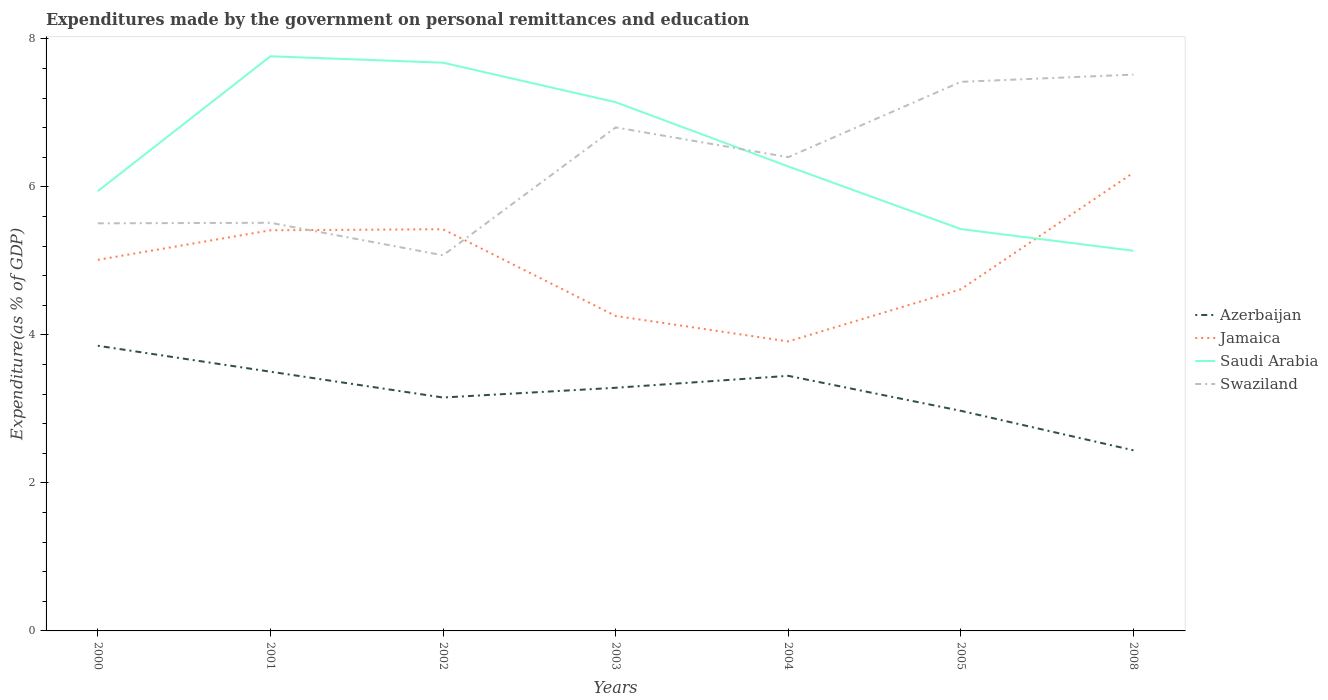How many different coloured lines are there?
Keep it short and to the point. 4. Does the line corresponding to Saudi Arabia intersect with the line corresponding to Jamaica?
Make the answer very short. Yes. Across all years, what is the maximum expenditures made by the government on personal remittances and education in Azerbaijan?
Make the answer very short. 2.44. What is the total expenditures made by the government on personal remittances and education in Azerbaijan in the graph?
Provide a short and direct response. 1.41. What is the difference between the highest and the second highest expenditures made by the government on personal remittances and education in Saudi Arabia?
Provide a succinct answer. 2.63. What is the difference between the highest and the lowest expenditures made by the government on personal remittances and education in Azerbaijan?
Ensure brevity in your answer.  4. Is the expenditures made by the government on personal remittances and education in Swaziland strictly greater than the expenditures made by the government on personal remittances and education in Jamaica over the years?
Provide a succinct answer. No. How many years are there in the graph?
Offer a terse response. 7. What is the difference between two consecutive major ticks on the Y-axis?
Offer a very short reply. 2. Are the values on the major ticks of Y-axis written in scientific E-notation?
Provide a short and direct response. No. Does the graph contain any zero values?
Your answer should be very brief. No. Does the graph contain grids?
Provide a short and direct response. No. Where does the legend appear in the graph?
Give a very brief answer. Center right. How many legend labels are there?
Provide a short and direct response. 4. What is the title of the graph?
Your answer should be very brief. Expenditures made by the government on personal remittances and education. Does "Hong Kong" appear as one of the legend labels in the graph?
Keep it short and to the point. No. What is the label or title of the Y-axis?
Provide a succinct answer. Expenditure(as % of GDP). What is the Expenditure(as % of GDP) of Azerbaijan in 2000?
Give a very brief answer. 3.85. What is the Expenditure(as % of GDP) of Jamaica in 2000?
Keep it short and to the point. 5.02. What is the Expenditure(as % of GDP) in Saudi Arabia in 2000?
Offer a very short reply. 5.94. What is the Expenditure(as % of GDP) in Swaziland in 2000?
Your answer should be compact. 5.51. What is the Expenditure(as % of GDP) in Azerbaijan in 2001?
Offer a very short reply. 3.5. What is the Expenditure(as % of GDP) in Jamaica in 2001?
Make the answer very short. 5.41. What is the Expenditure(as % of GDP) of Saudi Arabia in 2001?
Your answer should be compact. 7.77. What is the Expenditure(as % of GDP) of Swaziland in 2001?
Your response must be concise. 5.52. What is the Expenditure(as % of GDP) of Azerbaijan in 2002?
Your answer should be very brief. 3.15. What is the Expenditure(as % of GDP) in Jamaica in 2002?
Make the answer very short. 5.43. What is the Expenditure(as % of GDP) of Saudi Arabia in 2002?
Your response must be concise. 7.68. What is the Expenditure(as % of GDP) of Swaziland in 2002?
Provide a short and direct response. 5.08. What is the Expenditure(as % of GDP) in Azerbaijan in 2003?
Offer a very short reply. 3.29. What is the Expenditure(as % of GDP) of Jamaica in 2003?
Offer a terse response. 4.26. What is the Expenditure(as % of GDP) in Saudi Arabia in 2003?
Keep it short and to the point. 7.15. What is the Expenditure(as % of GDP) of Swaziland in 2003?
Make the answer very short. 6.81. What is the Expenditure(as % of GDP) of Azerbaijan in 2004?
Offer a terse response. 3.45. What is the Expenditure(as % of GDP) in Jamaica in 2004?
Make the answer very short. 3.91. What is the Expenditure(as % of GDP) in Saudi Arabia in 2004?
Provide a succinct answer. 6.28. What is the Expenditure(as % of GDP) of Swaziland in 2004?
Provide a succinct answer. 6.4. What is the Expenditure(as % of GDP) of Azerbaijan in 2005?
Give a very brief answer. 2.97. What is the Expenditure(as % of GDP) in Jamaica in 2005?
Your answer should be compact. 4.62. What is the Expenditure(as % of GDP) of Saudi Arabia in 2005?
Provide a succinct answer. 5.43. What is the Expenditure(as % of GDP) of Swaziland in 2005?
Your answer should be compact. 7.42. What is the Expenditure(as % of GDP) in Azerbaijan in 2008?
Offer a very short reply. 2.44. What is the Expenditure(as % of GDP) of Jamaica in 2008?
Your answer should be compact. 6.19. What is the Expenditure(as % of GDP) in Saudi Arabia in 2008?
Offer a terse response. 5.14. What is the Expenditure(as % of GDP) of Swaziland in 2008?
Offer a very short reply. 7.52. Across all years, what is the maximum Expenditure(as % of GDP) of Azerbaijan?
Your response must be concise. 3.85. Across all years, what is the maximum Expenditure(as % of GDP) of Jamaica?
Give a very brief answer. 6.19. Across all years, what is the maximum Expenditure(as % of GDP) of Saudi Arabia?
Your answer should be compact. 7.77. Across all years, what is the maximum Expenditure(as % of GDP) in Swaziland?
Keep it short and to the point. 7.52. Across all years, what is the minimum Expenditure(as % of GDP) of Azerbaijan?
Keep it short and to the point. 2.44. Across all years, what is the minimum Expenditure(as % of GDP) in Jamaica?
Your answer should be very brief. 3.91. Across all years, what is the minimum Expenditure(as % of GDP) in Saudi Arabia?
Offer a terse response. 5.14. Across all years, what is the minimum Expenditure(as % of GDP) in Swaziland?
Make the answer very short. 5.08. What is the total Expenditure(as % of GDP) in Azerbaijan in the graph?
Your answer should be very brief. 22.66. What is the total Expenditure(as % of GDP) in Jamaica in the graph?
Your response must be concise. 34.84. What is the total Expenditure(as % of GDP) of Saudi Arabia in the graph?
Provide a succinct answer. 45.38. What is the total Expenditure(as % of GDP) in Swaziland in the graph?
Provide a short and direct response. 44.25. What is the difference between the Expenditure(as % of GDP) of Azerbaijan in 2000 and that in 2001?
Offer a terse response. 0.35. What is the difference between the Expenditure(as % of GDP) of Jamaica in 2000 and that in 2001?
Give a very brief answer. -0.4. What is the difference between the Expenditure(as % of GDP) of Saudi Arabia in 2000 and that in 2001?
Keep it short and to the point. -1.82. What is the difference between the Expenditure(as % of GDP) in Swaziland in 2000 and that in 2001?
Provide a succinct answer. -0.01. What is the difference between the Expenditure(as % of GDP) in Azerbaijan in 2000 and that in 2002?
Make the answer very short. 0.7. What is the difference between the Expenditure(as % of GDP) of Jamaica in 2000 and that in 2002?
Offer a terse response. -0.41. What is the difference between the Expenditure(as % of GDP) of Saudi Arabia in 2000 and that in 2002?
Give a very brief answer. -1.74. What is the difference between the Expenditure(as % of GDP) of Swaziland in 2000 and that in 2002?
Offer a terse response. 0.43. What is the difference between the Expenditure(as % of GDP) in Azerbaijan in 2000 and that in 2003?
Your answer should be very brief. 0.57. What is the difference between the Expenditure(as % of GDP) in Jamaica in 2000 and that in 2003?
Your answer should be very brief. 0.76. What is the difference between the Expenditure(as % of GDP) in Saudi Arabia in 2000 and that in 2003?
Your answer should be very brief. -1.2. What is the difference between the Expenditure(as % of GDP) of Swaziland in 2000 and that in 2003?
Give a very brief answer. -1.3. What is the difference between the Expenditure(as % of GDP) of Azerbaijan in 2000 and that in 2004?
Your response must be concise. 0.41. What is the difference between the Expenditure(as % of GDP) in Jamaica in 2000 and that in 2004?
Offer a terse response. 1.1. What is the difference between the Expenditure(as % of GDP) in Saudi Arabia in 2000 and that in 2004?
Ensure brevity in your answer.  -0.33. What is the difference between the Expenditure(as % of GDP) in Swaziland in 2000 and that in 2004?
Provide a short and direct response. -0.89. What is the difference between the Expenditure(as % of GDP) of Azerbaijan in 2000 and that in 2005?
Your response must be concise. 0.88. What is the difference between the Expenditure(as % of GDP) in Jamaica in 2000 and that in 2005?
Provide a short and direct response. 0.4. What is the difference between the Expenditure(as % of GDP) of Saudi Arabia in 2000 and that in 2005?
Your answer should be compact. 0.51. What is the difference between the Expenditure(as % of GDP) in Swaziland in 2000 and that in 2005?
Provide a short and direct response. -1.91. What is the difference between the Expenditure(as % of GDP) in Azerbaijan in 2000 and that in 2008?
Provide a succinct answer. 1.41. What is the difference between the Expenditure(as % of GDP) in Jamaica in 2000 and that in 2008?
Keep it short and to the point. -1.18. What is the difference between the Expenditure(as % of GDP) of Saudi Arabia in 2000 and that in 2008?
Offer a terse response. 0.81. What is the difference between the Expenditure(as % of GDP) in Swaziland in 2000 and that in 2008?
Your answer should be compact. -2.01. What is the difference between the Expenditure(as % of GDP) in Azerbaijan in 2001 and that in 2002?
Ensure brevity in your answer.  0.35. What is the difference between the Expenditure(as % of GDP) of Jamaica in 2001 and that in 2002?
Offer a terse response. -0.01. What is the difference between the Expenditure(as % of GDP) in Saudi Arabia in 2001 and that in 2002?
Provide a succinct answer. 0.09. What is the difference between the Expenditure(as % of GDP) of Swaziland in 2001 and that in 2002?
Your answer should be very brief. 0.44. What is the difference between the Expenditure(as % of GDP) in Azerbaijan in 2001 and that in 2003?
Offer a terse response. 0.22. What is the difference between the Expenditure(as % of GDP) of Jamaica in 2001 and that in 2003?
Ensure brevity in your answer.  1.16. What is the difference between the Expenditure(as % of GDP) of Saudi Arabia in 2001 and that in 2003?
Your response must be concise. 0.62. What is the difference between the Expenditure(as % of GDP) of Swaziland in 2001 and that in 2003?
Offer a very short reply. -1.29. What is the difference between the Expenditure(as % of GDP) of Azerbaijan in 2001 and that in 2004?
Ensure brevity in your answer.  0.06. What is the difference between the Expenditure(as % of GDP) in Jamaica in 2001 and that in 2004?
Give a very brief answer. 1.5. What is the difference between the Expenditure(as % of GDP) in Saudi Arabia in 2001 and that in 2004?
Make the answer very short. 1.49. What is the difference between the Expenditure(as % of GDP) of Swaziland in 2001 and that in 2004?
Your response must be concise. -0.89. What is the difference between the Expenditure(as % of GDP) of Azerbaijan in 2001 and that in 2005?
Ensure brevity in your answer.  0.53. What is the difference between the Expenditure(as % of GDP) in Jamaica in 2001 and that in 2005?
Offer a very short reply. 0.8. What is the difference between the Expenditure(as % of GDP) of Saudi Arabia in 2001 and that in 2005?
Your response must be concise. 2.34. What is the difference between the Expenditure(as % of GDP) of Swaziland in 2001 and that in 2005?
Your response must be concise. -1.9. What is the difference between the Expenditure(as % of GDP) of Jamaica in 2001 and that in 2008?
Make the answer very short. -0.78. What is the difference between the Expenditure(as % of GDP) in Saudi Arabia in 2001 and that in 2008?
Give a very brief answer. 2.63. What is the difference between the Expenditure(as % of GDP) of Swaziland in 2001 and that in 2008?
Your answer should be compact. -2. What is the difference between the Expenditure(as % of GDP) in Azerbaijan in 2002 and that in 2003?
Give a very brief answer. -0.13. What is the difference between the Expenditure(as % of GDP) of Jamaica in 2002 and that in 2003?
Your answer should be very brief. 1.17. What is the difference between the Expenditure(as % of GDP) in Saudi Arabia in 2002 and that in 2003?
Make the answer very short. 0.53. What is the difference between the Expenditure(as % of GDP) in Swaziland in 2002 and that in 2003?
Your response must be concise. -1.73. What is the difference between the Expenditure(as % of GDP) of Azerbaijan in 2002 and that in 2004?
Make the answer very short. -0.29. What is the difference between the Expenditure(as % of GDP) in Jamaica in 2002 and that in 2004?
Make the answer very short. 1.52. What is the difference between the Expenditure(as % of GDP) in Saudi Arabia in 2002 and that in 2004?
Give a very brief answer. 1.4. What is the difference between the Expenditure(as % of GDP) of Swaziland in 2002 and that in 2004?
Provide a succinct answer. -1.33. What is the difference between the Expenditure(as % of GDP) of Azerbaijan in 2002 and that in 2005?
Your response must be concise. 0.18. What is the difference between the Expenditure(as % of GDP) in Jamaica in 2002 and that in 2005?
Your answer should be compact. 0.81. What is the difference between the Expenditure(as % of GDP) of Saudi Arabia in 2002 and that in 2005?
Your answer should be compact. 2.25. What is the difference between the Expenditure(as % of GDP) in Swaziland in 2002 and that in 2005?
Keep it short and to the point. -2.34. What is the difference between the Expenditure(as % of GDP) in Azerbaijan in 2002 and that in 2008?
Offer a very short reply. 0.71. What is the difference between the Expenditure(as % of GDP) of Jamaica in 2002 and that in 2008?
Offer a very short reply. -0.76. What is the difference between the Expenditure(as % of GDP) in Saudi Arabia in 2002 and that in 2008?
Keep it short and to the point. 2.54. What is the difference between the Expenditure(as % of GDP) of Swaziland in 2002 and that in 2008?
Make the answer very short. -2.44. What is the difference between the Expenditure(as % of GDP) in Azerbaijan in 2003 and that in 2004?
Keep it short and to the point. -0.16. What is the difference between the Expenditure(as % of GDP) of Jamaica in 2003 and that in 2004?
Provide a short and direct response. 0.34. What is the difference between the Expenditure(as % of GDP) in Saudi Arabia in 2003 and that in 2004?
Your answer should be compact. 0.87. What is the difference between the Expenditure(as % of GDP) in Swaziland in 2003 and that in 2004?
Offer a very short reply. 0.4. What is the difference between the Expenditure(as % of GDP) of Azerbaijan in 2003 and that in 2005?
Provide a short and direct response. 0.31. What is the difference between the Expenditure(as % of GDP) of Jamaica in 2003 and that in 2005?
Give a very brief answer. -0.36. What is the difference between the Expenditure(as % of GDP) in Saudi Arabia in 2003 and that in 2005?
Offer a very short reply. 1.72. What is the difference between the Expenditure(as % of GDP) in Swaziland in 2003 and that in 2005?
Give a very brief answer. -0.62. What is the difference between the Expenditure(as % of GDP) in Azerbaijan in 2003 and that in 2008?
Your answer should be very brief. 0.85. What is the difference between the Expenditure(as % of GDP) of Jamaica in 2003 and that in 2008?
Your answer should be compact. -1.94. What is the difference between the Expenditure(as % of GDP) of Saudi Arabia in 2003 and that in 2008?
Your answer should be very brief. 2.01. What is the difference between the Expenditure(as % of GDP) in Swaziland in 2003 and that in 2008?
Your response must be concise. -0.71. What is the difference between the Expenditure(as % of GDP) in Azerbaijan in 2004 and that in 2005?
Offer a terse response. 0.47. What is the difference between the Expenditure(as % of GDP) of Jamaica in 2004 and that in 2005?
Your answer should be very brief. -0.7. What is the difference between the Expenditure(as % of GDP) in Saudi Arabia in 2004 and that in 2005?
Provide a succinct answer. 0.85. What is the difference between the Expenditure(as % of GDP) in Swaziland in 2004 and that in 2005?
Ensure brevity in your answer.  -1.02. What is the difference between the Expenditure(as % of GDP) of Azerbaijan in 2004 and that in 2008?
Your answer should be compact. 1.01. What is the difference between the Expenditure(as % of GDP) of Jamaica in 2004 and that in 2008?
Ensure brevity in your answer.  -2.28. What is the difference between the Expenditure(as % of GDP) of Saudi Arabia in 2004 and that in 2008?
Make the answer very short. 1.14. What is the difference between the Expenditure(as % of GDP) in Swaziland in 2004 and that in 2008?
Give a very brief answer. -1.12. What is the difference between the Expenditure(as % of GDP) of Azerbaijan in 2005 and that in 2008?
Give a very brief answer. 0.53. What is the difference between the Expenditure(as % of GDP) in Jamaica in 2005 and that in 2008?
Offer a very short reply. -1.58. What is the difference between the Expenditure(as % of GDP) in Saudi Arabia in 2005 and that in 2008?
Your response must be concise. 0.29. What is the difference between the Expenditure(as % of GDP) in Swaziland in 2005 and that in 2008?
Your answer should be very brief. -0.1. What is the difference between the Expenditure(as % of GDP) in Azerbaijan in 2000 and the Expenditure(as % of GDP) in Jamaica in 2001?
Your answer should be compact. -1.56. What is the difference between the Expenditure(as % of GDP) in Azerbaijan in 2000 and the Expenditure(as % of GDP) in Saudi Arabia in 2001?
Your answer should be very brief. -3.91. What is the difference between the Expenditure(as % of GDP) in Azerbaijan in 2000 and the Expenditure(as % of GDP) in Swaziland in 2001?
Your answer should be compact. -1.66. What is the difference between the Expenditure(as % of GDP) of Jamaica in 2000 and the Expenditure(as % of GDP) of Saudi Arabia in 2001?
Make the answer very short. -2.75. What is the difference between the Expenditure(as % of GDP) of Jamaica in 2000 and the Expenditure(as % of GDP) of Swaziland in 2001?
Your answer should be very brief. -0.5. What is the difference between the Expenditure(as % of GDP) of Saudi Arabia in 2000 and the Expenditure(as % of GDP) of Swaziland in 2001?
Give a very brief answer. 0.43. What is the difference between the Expenditure(as % of GDP) in Azerbaijan in 2000 and the Expenditure(as % of GDP) in Jamaica in 2002?
Give a very brief answer. -1.57. What is the difference between the Expenditure(as % of GDP) in Azerbaijan in 2000 and the Expenditure(as % of GDP) in Saudi Arabia in 2002?
Keep it short and to the point. -3.83. What is the difference between the Expenditure(as % of GDP) in Azerbaijan in 2000 and the Expenditure(as % of GDP) in Swaziland in 2002?
Your answer should be very brief. -1.22. What is the difference between the Expenditure(as % of GDP) in Jamaica in 2000 and the Expenditure(as % of GDP) in Saudi Arabia in 2002?
Make the answer very short. -2.66. What is the difference between the Expenditure(as % of GDP) of Jamaica in 2000 and the Expenditure(as % of GDP) of Swaziland in 2002?
Give a very brief answer. -0.06. What is the difference between the Expenditure(as % of GDP) of Saudi Arabia in 2000 and the Expenditure(as % of GDP) of Swaziland in 2002?
Offer a terse response. 0.87. What is the difference between the Expenditure(as % of GDP) in Azerbaijan in 2000 and the Expenditure(as % of GDP) in Jamaica in 2003?
Keep it short and to the point. -0.4. What is the difference between the Expenditure(as % of GDP) of Azerbaijan in 2000 and the Expenditure(as % of GDP) of Saudi Arabia in 2003?
Keep it short and to the point. -3.29. What is the difference between the Expenditure(as % of GDP) in Azerbaijan in 2000 and the Expenditure(as % of GDP) in Swaziland in 2003?
Keep it short and to the point. -2.95. What is the difference between the Expenditure(as % of GDP) of Jamaica in 2000 and the Expenditure(as % of GDP) of Saudi Arabia in 2003?
Make the answer very short. -2.13. What is the difference between the Expenditure(as % of GDP) of Jamaica in 2000 and the Expenditure(as % of GDP) of Swaziland in 2003?
Your answer should be compact. -1.79. What is the difference between the Expenditure(as % of GDP) of Saudi Arabia in 2000 and the Expenditure(as % of GDP) of Swaziland in 2003?
Provide a short and direct response. -0.86. What is the difference between the Expenditure(as % of GDP) in Azerbaijan in 2000 and the Expenditure(as % of GDP) in Jamaica in 2004?
Provide a short and direct response. -0.06. What is the difference between the Expenditure(as % of GDP) in Azerbaijan in 2000 and the Expenditure(as % of GDP) in Saudi Arabia in 2004?
Give a very brief answer. -2.42. What is the difference between the Expenditure(as % of GDP) in Azerbaijan in 2000 and the Expenditure(as % of GDP) in Swaziland in 2004?
Provide a succinct answer. -2.55. What is the difference between the Expenditure(as % of GDP) of Jamaica in 2000 and the Expenditure(as % of GDP) of Saudi Arabia in 2004?
Offer a very short reply. -1.26. What is the difference between the Expenditure(as % of GDP) of Jamaica in 2000 and the Expenditure(as % of GDP) of Swaziland in 2004?
Offer a very short reply. -1.39. What is the difference between the Expenditure(as % of GDP) in Saudi Arabia in 2000 and the Expenditure(as % of GDP) in Swaziland in 2004?
Offer a terse response. -0.46. What is the difference between the Expenditure(as % of GDP) in Azerbaijan in 2000 and the Expenditure(as % of GDP) in Jamaica in 2005?
Your answer should be compact. -0.76. What is the difference between the Expenditure(as % of GDP) in Azerbaijan in 2000 and the Expenditure(as % of GDP) in Saudi Arabia in 2005?
Provide a short and direct response. -1.58. What is the difference between the Expenditure(as % of GDP) in Azerbaijan in 2000 and the Expenditure(as % of GDP) in Swaziland in 2005?
Make the answer very short. -3.57. What is the difference between the Expenditure(as % of GDP) in Jamaica in 2000 and the Expenditure(as % of GDP) in Saudi Arabia in 2005?
Give a very brief answer. -0.42. What is the difference between the Expenditure(as % of GDP) of Jamaica in 2000 and the Expenditure(as % of GDP) of Swaziland in 2005?
Your response must be concise. -2.41. What is the difference between the Expenditure(as % of GDP) of Saudi Arabia in 2000 and the Expenditure(as % of GDP) of Swaziland in 2005?
Provide a succinct answer. -1.48. What is the difference between the Expenditure(as % of GDP) of Azerbaijan in 2000 and the Expenditure(as % of GDP) of Jamaica in 2008?
Provide a short and direct response. -2.34. What is the difference between the Expenditure(as % of GDP) in Azerbaijan in 2000 and the Expenditure(as % of GDP) in Saudi Arabia in 2008?
Your answer should be compact. -1.28. What is the difference between the Expenditure(as % of GDP) of Azerbaijan in 2000 and the Expenditure(as % of GDP) of Swaziland in 2008?
Ensure brevity in your answer.  -3.66. What is the difference between the Expenditure(as % of GDP) of Jamaica in 2000 and the Expenditure(as % of GDP) of Saudi Arabia in 2008?
Your answer should be very brief. -0.12. What is the difference between the Expenditure(as % of GDP) in Jamaica in 2000 and the Expenditure(as % of GDP) in Swaziland in 2008?
Your answer should be very brief. -2.5. What is the difference between the Expenditure(as % of GDP) of Saudi Arabia in 2000 and the Expenditure(as % of GDP) of Swaziland in 2008?
Give a very brief answer. -1.58. What is the difference between the Expenditure(as % of GDP) of Azerbaijan in 2001 and the Expenditure(as % of GDP) of Jamaica in 2002?
Ensure brevity in your answer.  -1.93. What is the difference between the Expenditure(as % of GDP) in Azerbaijan in 2001 and the Expenditure(as % of GDP) in Saudi Arabia in 2002?
Ensure brevity in your answer.  -4.18. What is the difference between the Expenditure(as % of GDP) in Azerbaijan in 2001 and the Expenditure(as % of GDP) in Swaziland in 2002?
Provide a short and direct response. -1.57. What is the difference between the Expenditure(as % of GDP) of Jamaica in 2001 and the Expenditure(as % of GDP) of Saudi Arabia in 2002?
Keep it short and to the point. -2.26. What is the difference between the Expenditure(as % of GDP) in Jamaica in 2001 and the Expenditure(as % of GDP) in Swaziland in 2002?
Your response must be concise. 0.34. What is the difference between the Expenditure(as % of GDP) of Saudi Arabia in 2001 and the Expenditure(as % of GDP) of Swaziland in 2002?
Your answer should be compact. 2.69. What is the difference between the Expenditure(as % of GDP) of Azerbaijan in 2001 and the Expenditure(as % of GDP) of Jamaica in 2003?
Give a very brief answer. -0.75. What is the difference between the Expenditure(as % of GDP) in Azerbaijan in 2001 and the Expenditure(as % of GDP) in Saudi Arabia in 2003?
Give a very brief answer. -3.64. What is the difference between the Expenditure(as % of GDP) in Azerbaijan in 2001 and the Expenditure(as % of GDP) in Swaziland in 2003?
Offer a terse response. -3.3. What is the difference between the Expenditure(as % of GDP) of Jamaica in 2001 and the Expenditure(as % of GDP) of Saudi Arabia in 2003?
Keep it short and to the point. -1.73. What is the difference between the Expenditure(as % of GDP) in Jamaica in 2001 and the Expenditure(as % of GDP) in Swaziland in 2003?
Your answer should be compact. -1.39. What is the difference between the Expenditure(as % of GDP) of Saudi Arabia in 2001 and the Expenditure(as % of GDP) of Swaziland in 2003?
Provide a short and direct response. 0.96. What is the difference between the Expenditure(as % of GDP) of Azerbaijan in 2001 and the Expenditure(as % of GDP) of Jamaica in 2004?
Provide a short and direct response. -0.41. What is the difference between the Expenditure(as % of GDP) in Azerbaijan in 2001 and the Expenditure(as % of GDP) in Saudi Arabia in 2004?
Give a very brief answer. -2.77. What is the difference between the Expenditure(as % of GDP) of Azerbaijan in 2001 and the Expenditure(as % of GDP) of Swaziland in 2004?
Offer a terse response. -2.9. What is the difference between the Expenditure(as % of GDP) of Jamaica in 2001 and the Expenditure(as % of GDP) of Saudi Arabia in 2004?
Your response must be concise. -0.86. What is the difference between the Expenditure(as % of GDP) of Jamaica in 2001 and the Expenditure(as % of GDP) of Swaziland in 2004?
Your response must be concise. -0.99. What is the difference between the Expenditure(as % of GDP) in Saudi Arabia in 2001 and the Expenditure(as % of GDP) in Swaziland in 2004?
Give a very brief answer. 1.36. What is the difference between the Expenditure(as % of GDP) in Azerbaijan in 2001 and the Expenditure(as % of GDP) in Jamaica in 2005?
Make the answer very short. -1.11. What is the difference between the Expenditure(as % of GDP) of Azerbaijan in 2001 and the Expenditure(as % of GDP) of Saudi Arabia in 2005?
Give a very brief answer. -1.93. What is the difference between the Expenditure(as % of GDP) of Azerbaijan in 2001 and the Expenditure(as % of GDP) of Swaziland in 2005?
Your answer should be compact. -3.92. What is the difference between the Expenditure(as % of GDP) in Jamaica in 2001 and the Expenditure(as % of GDP) in Saudi Arabia in 2005?
Your answer should be very brief. -0.02. What is the difference between the Expenditure(as % of GDP) in Jamaica in 2001 and the Expenditure(as % of GDP) in Swaziland in 2005?
Make the answer very short. -2.01. What is the difference between the Expenditure(as % of GDP) of Saudi Arabia in 2001 and the Expenditure(as % of GDP) of Swaziland in 2005?
Give a very brief answer. 0.35. What is the difference between the Expenditure(as % of GDP) of Azerbaijan in 2001 and the Expenditure(as % of GDP) of Jamaica in 2008?
Offer a very short reply. -2.69. What is the difference between the Expenditure(as % of GDP) in Azerbaijan in 2001 and the Expenditure(as % of GDP) in Saudi Arabia in 2008?
Offer a terse response. -1.63. What is the difference between the Expenditure(as % of GDP) in Azerbaijan in 2001 and the Expenditure(as % of GDP) in Swaziland in 2008?
Provide a succinct answer. -4.02. What is the difference between the Expenditure(as % of GDP) of Jamaica in 2001 and the Expenditure(as % of GDP) of Saudi Arabia in 2008?
Offer a terse response. 0.28. What is the difference between the Expenditure(as % of GDP) of Jamaica in 2001 and the Expenditure(as % of GDP) of Swaziland in 2008?
Offer a terse response. -2.1. What is the difference between the Expenditure(as % of GDP) of Saudi Arabia in 2001 and the Expenditure(as % of GDP) of Swaziland in 2008?
Provide a succinct answer. 0.25. What is the difference between the Expenditure(as % of GDP) in Azerbaijan in 2002 and the Expenditure(as % of GDP) in Jamaica in 2003?
Your response must be concise. -1.1. What is the difference between the Expenditure(as % of GDP) of Azerbaijan in 2002 and the Expenditure(as % of GDP) of Saudi Arabia in 2003?
Keep it short and to the point. -3.99. What is the difference between the Expenditure(as % of GDP) of Azerbaijan in 2002 and the Expenditure(as % of GDP) of Swaziland in 2003?
Give a very brief answer. -3.65. What is the difference between the Expenditure(as % of GDP) of Jamaica in 2002 and the Expenditure(as % of GDP) of Saudi Arabia in 2003?
Make the answer very short. -1.72. What is the difference between the Expenditure(as % of GDP) in Jamaica in 2002 and the Expenditure(as % of GDP) in Swaziland in 2003?
Give a very brief answer. -1.38. What is the difference between the Expenditure(as % of GDP) of Saudi Arabia in 2002 and the Expenditure(as % of GDP) of Swaziland in 2003?
Your response must be concise. 0.87. What is the difference between the Expenditure(as % of GDP) of Azerbaijan in 2002 and the Expenditure(as % of GDP) of Jamaica in 2004?
Offer a very short reply. -0.76. What is the difference between the Expenditure(as % of GDP) in Azerbaijan in 2002 and the Expenditure(as % of GDP) in Saudi Arabia in 2004?
Your answer should be compact. -3.12. What is the difference between the Expenditure(as % of GDP) in Azerbaijan in 2002 and the Expenditure(as % of GDP) in Swaziland in 2004?
Your answer should be compact. -3.25. What is the difference between the Expenditure(as % of GDP) of Jamaica in 2002 and the Expenditure(as % of GDP) of Saudi Arabia in 2004?
Give a very brief answer. -0.85. What is the difference between the Expenditure(as % of GDP) in Jamaica in 2002 and the Expenditure(as % of GDP) in Swaziland in 2004?
Provide a succinct answer. -0.97. What is the difference between the Expenditure(as % of GDP) of Saudi Arabia in 2002 and the Expenditure(as % of GDP) of Swaziland in 2004?
Provide a short and direct response. 1.28. What is the difference between the Expenditure(as % of GDP) in Azerbaijan in 2002 and the Expenditure(as % of GDP) in Jamaica in 2005?
Offer a very short reply. -1.46. What is the difference between the Expenditure(as % of GDP) in Azerbaijan in 2002 and the Expenditure(as % of GDP) in Saudi Arabia in 2005?
Keep it short and to the point. -2.28. What is the difference between the Expenditure(as % of GDP) of Azerbaijan in 2002 and the Expenditure(as % of GDP) of Swaziland in 2005?
Your answer should be compact. -4.27. What is the difference between the Expenditure(as % of GDP) of Jamaica in 2002 and the Expenditure(as % of GDP) of Saudi Arabia in 2005?
Provide a succinct answer. -0. What is the difference between the Expenditure(as % of GDP) in Jamaica in 2002 and the Expenditure(as % of GDP) in Swaziland in 2005?
Provide a succinct answer. -1.99. What is the difference between the Expenditure(as % of GDP) in Saudi Arabia in 2002 and the Expenditure(as % of GDP) in Swaziland in 2005?
Give a very brief answer. 0.26. What is the difference between the Expenditure(as % of GDP) in Azerbaijan in 2002 and the Expenditure(as % of GDP) in Jamaica in 2008?
Your response must be concise. -3.04. What is the difference between the Expenditure(as % of GDP) of Azerbaijan in 2002 and the Expenditure(as % of GDP) of Saudi Arabia in 2008?
Your answer should be very brief. -1.98. What is the difference between the Expenditure(as % of GDP) of Azerbaijan in 2002 and the Expenditure(as % of GDP) of Swaziland in 2008?
Offer a terse response. -4.36. What is the difference between the Expenditure(as % of GDP) of Jamaica in 2002 and the Expenditure(as % of GDP) of Saudi Arabia in 2008?
Your answer should be very brief. 0.29. What is the difference between the Expenditure(as % of GDP) in Jamaica in 2002 and the Expenditure(as % of GDP) in Swaziland in 2008?
Your answer should be very brief. -2.09. What is the difference between the Expenditure(as % of GDP) of Saudi Arabia in 2002 and the Expenditure(as % of GDP) of Swaziland in 2008?
Give a very brief answer. 0.16. What is the difference between the Expenditure(as % of GDP) of Azerbaijan in 2003 and the Expenditure(as % of GDP) of Jamaica in 2004?
Ensure brevity in your answer.  -0.63. What is the difference between the Expenditure(as % of GDP) of Azerbaijan in 2003 and the Expenditure(as % of GDP) of Saudi Arabia in 2004?
Make the answer very short. -2.99. What is the difference between the Expenditure(as % of GDP) of Azerbaijan in 2003 and the Expenditure(as % of GDP) of Swaziland in 2004?
Offer a terse response. -3.12. What is the difference between the Expenditure(as % of GDP) of Jamaica in 2003 and the Expenditure(as % of GDP) of Saudi Arabia in 2004?
Make the answer very short. -2.02. What is the difference between the Expenditure(as % of GDP) of Jamaica in 2003 and the Expenditure(as % of GDP) of Swaziland in 2004?
Offer a very short reply. -2.15. What is the difference between the Expenditure(as % of GDP) of Saudi Arabia in 2003 and the Expenditure(as % of GDP) of Swaziland in 2004?
Offer a very short reply. 0.74. What is the difference between the Expenditure(as % of GDP) of Azerbaijan in 2003 and the Expenditure(as % of GDP) of Jamaica in 2005?
Provide a succinct answer. -1.33. What is the difference between the Expenditure(as % of GDP) in Azerbaijan in 2003 and the Expenditure(as % of GDP) in Saudi Arabia in 2005?
Ensure brevity in your answer.  -2.14. What is the difference between the Expenditure(as % of GDP) in Azerbaijan in 2003 and the Expenditure(as % of GDP) in Swaziland in 2005?
Offer a very short reply. -4.13. What is the difference between the Expenditure(as % of GDP) of Jamaica in 2003 and the Expenditure(as % of GDP) of Saudi Arabia in 2005?
Your answer should be very brief. -1.17. What is the difference between the Expenditure(as % of GDP) in Jamaica in 2003 and the Expenditure(as % of GDP) in Swaziland in 2005?
Your answer should be very brief. -3.16. What is the difference between the Expenditure(as % of GDP) in Saudi Arabia in 2003 and the Expenditure(as % of GDP) in Swaziland in 2005?
Give a very brief answer. -0.27. What is the difference between the Expenditure(as % of GDP) in Azerbaijan in 2003 and the Expenditure(as % of GDP) in Jamaica in 2008?
Provide a succinct answer. -2.91. What is the difference between the Expenditure(as % of GDP) in Azerbaijan in 2003 and the Expenditure(as % of GDP) in Saudi Arabia in 2008?
Provide a succinct answer. -1.85. What is the difference between the Expenditure(as % of GDP) in Azerbaijan in 2003 and the Expenditure(as % of GDP) in Swaziland in 2008?
Give a very brief answer. -4.23. What is the difference between the Expenditure(as % of GDP) in Jamaica in 2003 and the Expenditure(as % of GDP) in Saudi Arabia in 2008?
Ensure brevity in your answer.  -0.88. What is the difference between the Expenditure(as % of GDP) in Jamaica in 2003 and the Expenditure(as % of GDP) in Swaziland in 2008?
Make the answer very short. -3.26. What is the difference between the Expenditure(as % of GDP) of Saudi Arabia in 2003 and the Expenditure(as % of GDP) of Swaziland in 2008?
Make the answer very short. -0.37. What is the difference between the Expenditure(as % of GDP) in Azerbaijan in 2004 and the Expenditure(as % of GDP) in Jamaica in 2005?
Your answer should be very brief. -1.17. What is the difference between the Expenditure(as % of GDP) of Azerbaijan in 2004 and the Expenditure(as % of GDP) of Saudi Arabia in 2005?
Offer a terse response. -1.98. What is the difference between the Expenditure(as % of GDP) of Azerbaijan in 2004 and the Expenditure(as % of GDP) of Swaziland in 2005?
Your answer should be compact. -3.97. What is the difference between the Expenditure(as % of GDP) in Jamaica in 2004 and the Expenditure(as % of GDP) in Saudi Arabia in 2005?
Provide a short and direct response. -1.52. What is the difference between the Expenditure(as % of GDP) of Jamaica in 2004 and the Expenditure(as % of GDP) of Swaziland in 2005?
Provide a short and direct response. -3.51. What is the difference between the Expenditure(as % of GDP) in Saudi Arabia in 2004 and the Expenditure(as % of GDP) in Swaziland in 2005?
Keep it short and to the point. -1.14. What is the difference between the Expenditure(as % of GDP) in Azerbaijan in 2004 and the Expenditure(as % of GDP) in Jamaica in 2008?
Provide a short and direct response. -2.75. What is the difference between the Expenditure(as % of GDP) of Azerbaijan in 2004 and the Expenditure(as % of GDP) of Saudi Arabia in 2008?
Make the answer very short. -1.69. What is the difference between the Expenditure(as % of GDP) of Azerbaijan in 2004 and the Expenditure(as % of GDP) of Swaziland in 2008?
Offer a very short reply. -4.07. What is the difference between the Expenditure(as % of GDP) of Jamaica in 2004 and the Expenditure(as % of GDP) of Saudi Arabia in 2008?
Your response must be concise. -1.23. What is the difference between the Expenditure(as % of GDP) of Jamaica in 2004 and the Expenditure(as % of GDP) of Swaziland in 2008?
Provide a short and direct response. -3.61. What is the difference between the Expenditure(as % of GDP) in Saudi Arabia in 2004 and the Expenditure(as % of GDP) in Swaziland in 2008?
Offer a terse response. -1.24. What is the difference between the Expenditure(as % of GDP) of Azerbaijan in 2005 and the Expenditure(as % of GDP) of Jamaica in 2008?
Offer a terse response. -3.22. What is the difference between the Expenditure(as % of GDP) of Azerbaijan in 2005 and the Expenditure(as % of GDP) of Saudi Arabia in 2008?
Your answer should be very brief. -2.16. What is the difference between the Expenditure(as % of GDP) in Azerbaijan in 2005 and the Expenditure(as % of GDP) in Swaziland in 2008?
Offer a very short reply. -4.54. What is the difference between the Expenditure(as % of GDP) in Jamaica in 2005 and the Expenditure(as % of GDP) in Saudi Arabia in 2008?
Make the answer very short. -0.52. What is the difference between the Expenditure(as % of GDP) in Jamaica in 2005 and the Expenditure(as % of GDP) in Swaziland in 2008?
Ensure brevity in your answer.  -2.9. What is the difference between the Expenditure(as % of GDP) of Saudi Arabia in 2005 and the Expenditure(as % of GDP) of Swaziland in 2008?
Provide a short and direct response. -2.09. What is the average Expenditure(as % of GDP) in Azerbaijan per year?
Provide a short and direct response. 3.24. What is the average Expenditure(as % of GDP) in Jamaica per year?
Your response must be concise. 4.98. What is the average Expenditure(as % of GDP) of Saudi Arabia per year?
Ensure brevity in your answer.  6.48. What is the average Expenditure(as % of GDP) in Swaziland per year?
Ensure brevity in your answer.  6.32. In the year 2000, what is the difference between the Expenditure(as % of GDP) of Azerbaijan and Expenditure(as % of GDP) of Jamaica?
Keep it short and to the point. -1.16. In the year 2000, what is the difference between the Expenditure(as % of GDP) of Azerbaijan and Expenditure(as % of GDP) of Saudi Arabia?
Provide a short and direct response. -2.09. In the year 2000, what is the difference between the Expenditure(as % of GDP) of Azerbaijan and Expenditure(as % of GDP) of Swaziland?
Ensure brevity in your answer.  -1.65. In the year 2000, what is the difference between the Expenditure(as % of GDP) in Jamaica and Expenditure(as % of GDP) in Saudi Arabia?
Offer a terse response. -0.93. In the year 2000, what is the difference between the Expenditure(as % of GDP) of Jamaica and Expenditure(as % of GDP) of Swaziland?
Your answer should be compact. -0.49. In the year 2000, what is the difference between the Expenditure(as % of GDP) in Saudi Arabia and Expenditure(as % of GDP) in Swaziland?
Offer a terse response. 0.43. In the year 2001, what is the difference between the Expenditure(as % of GDP) of Azerbaijan and Expenditure(as % of GDP) of Jamaica?
Ensure brevity in your answer.  -1.91. In the year 2001, what is the difference between the Expenditure(as % of GDP) of Azerbaijan and Expenditure(as % of GDP) of Saudi Arabia?
Keep it short and to the point. -4.26. In the year 2001, what is the difference between the Expenditure(as % of GDP) of Azerbaijan and Expenditure(as % of GDP) of Swaziland?
Ensure brevity in your answer.  -2.01. In the year 2001, what is the difference between the Expenditure(as % of GDP) in Jamaica and Expenditure(as % of GDP) in Saudi Arabia?
Keep it short and to the point. -2.35. In the year 2001, what is the difference between the Expenditure(as % of GDP) in Jamaica and Expenditure(as % of GDP) in Swaziland?
Your response must be concise. -0.1. In the year 2001, what is the difference between the Expenditure(as % of GDP) in Saudi Arabia and Expenditure(as % of GDP) in Swaziland?
Provide a short and direct response. 2.25. In the year 2002, what is the difference between the Expenditure(as % of GDP) of Azerbaijan and Expenditure(as % of GDP) of Jamaica?
Make the answer very short. -2.27. In the year 2002, what is the difference between the Expenditure(as % of GDP) of Azerbaijan and Expenditure(as % of GDP) of Saudi Arabia?
Your answer should be very brief. -4.53. In the year 2002, what is the difference between the Expenditure(as % of GDP) in Azerbaijan and Expenditure(as % of GDP) in Swaziland?
Keep it short and to the point. -1.92. In the year 2002, what is the difference between the Expenditure(as % of GDP) in Jamaica and Expenditure(as % of GDP) in Saudi Arabia?
Provide a short and direct response. -2.25. In the year 2002, what is the difference between the Expenditure(as % of GDP) of Jamaica and Expenditure(as % of GDP) of Swaziland?
Provide a succinct answer. 0.35. In the year 2002, what is the difference between the Expenditure(as % of GDP) of Saudi Arabia and Expenditure(as % of GDP) of Swaziland?
Offer a terse response. 2.6. In the year 2003, what is the difference between the Expenditure(as % of GDP) in Azerbaijan and Expenditure(as % of GDP) in Jamaica?
Ensure brevity in your answer.  -0.97. In the year 2003, what is the difference between the Expenditure(as % of GDP) in Azerbaijan and Expenditure(as % of GDP) in Saudi Arabia?
Provide a succinct answer. -3.86. In the year 2003, what is the difference between the Expenditure(as % of GDP) of Azerbaijan and Expenditure(as % of GDP) of Swaziland?
Give a very brief answer. -3.52. In the year 2003, what is the difference between the Expenditure(as % of GDP) of Jamaica and Expenditure(as % of GDP) of Saudi Arabia?
Ensure brevity in your answer.  -2.89. In the year 2003, what is the difference between the Expenditure(as % of GDP) of Jamaica and Expenditure(as % of GDP) of Swaziland?
Your response must be concise. -2.55. In the year 2003, what is the difference between the Expenditure(as % of GDP) in Saudi Arabia and Expenditure(as % of GDP) in Swaziland?
Your answer should be very brief. 0.34. In the year 2004, what is the difference between the Expenditure(as % of GDP) of Azerbaijan and Expenditure(as % of GDP) of Jamaica?
Give a very brief answer. -0.46. In the year 2004, what is the difference between the Expenditure(as % of GDP) in Azerbaijan and Expenditure(as % of GDP) in Saudi Arabia?
Provide a succinct answer. -2.83. In the year 2004, what is the difference between the Expenditure(as % of GDP) in Azerbaijan and Expenditure(as % of GDP) in Swaziland?
Offer a very short reply. -2.95. In the year 2004, what is the difference between the Expenditure(as % of GDP) of Jamaica and Expenditure(as % of GDP) of Saudi Arabia?
Provide a short and direct response. -2.36. In the year 2004, what is the difference between the Expenditure(as % of GDP) of Jamaica and Expenditure(as % of GDP) of Swaziland?
Offer a terse response. -2.49. In the year 2004, what is the difference between the Expenditure(as % of GDP) in Saudi Arabia and Expenditure(as % of GDP) in Swaziland?
Keep it short and to the point. -0.13. In the year 2005, what is the difference between the Expenditure(as % of GDP) in Azerbaijan and Expenditure(as % of GDP) in Jamaica?
Ensure brevity in your answer.  -1.64. In the year 2005, what is the difference between the Expenditure(as % of GDP) of Azerbaijan and Expenditure(as % of GDP) of Saudi Arabia?
Offer a very short reply. -2.46. In the year 2005, what is the difference between the Expenditure(as % of GDP) of Azerbaijan and Expenditure(as % of GDP) of Swaziland?
Make the answer very short. -4.45. In the year 2005, what is the difference between the Expenditure(as % of GDP) of Jamaica and Expenditure(as % of GDP) of Saudi Arabia?
Your answer should be very brief. -0.81. In the year 2005, what is the difference between the Expenditure(as % of GDP) of Jamaica and Expenditure(as % of GDP) of Swaziland?
Ensure brevity in your answer.  -2.8. In the year 2005, what is the difference between the Expenditure(as % of GDP) of Saudi Arabia and Expenditure(as % of GDP) of Swaziland?
Provide a short and direct response. -1.99. In the year 2008, what is the difference between the Expenditure(as % of GDP) of Azerbaijan and Expenditure(as % of GDP) of Jamaica?
Your response must be concise. -3.75. In the year 2008, what is the difference between the Expenditure(as % of GDP) of Azerbaijan and Expenditure(as % of GDP) of Saudi Arabia?
Offer a very short reply. -2.7. In the year 2008, what is the difference between the Expenditure(as % of GDP) in Azerbaijan and Expenditure(as % of GDP) in Swaziland?
Offer a terse response. -5.08. In the year 2008, what is the difference between the Expenditure(as % of GDP) of Jamaica and Expenditure(as % of GDP) of Saudi Arabia?
Keep it short and to the point. 1.06. In the year 2008, what is the difference between the Expenditure(as % of GDP) in Jamaica and Expenditure(as % of GDP) in Swaziland?
Your answer should be compact. -1.33. In the year 2008, what is the difference between the Expenditure(as % of GDP) of Saudi Arabia and Expenditure(as % of GDP) of Swaziland?
Provide a short and direct response. -2.38. What is the ratio of the Expenditure(as % of GDP) in Azerbaijan in 2000 to that in 2001?
Offer a very short reply. 1.1. What is the ratio of the Expenditure(as % of GDP) of Jamaica in 2000 to that in 2001?
Keep it short and to the point. 0.93. What is the ratio of the Expenditure(as % of GDP) of Saudi Arabia in 2000 to that in 2001?
Provide a short and direct response. 0.77. What is the ratio of the Expenditure(as % of GDP) in Swaziland in 2000 to that in 2001?
Provide a succinct answer. 1. What is the ratio of the Expenditure(as % of GDP) of Azerbaijan in 2000 to that in 2002?
Offer a terse response. 1.22. What is the ratio of the Expenditure(as % of GDP) of Jamaica in 2000 to that in 2002?
Offer a very short reply. 0.92. What is the ratio of the Expenditure(as % of GDP) in Saudi Arabia in 2000 to that in 2002?
Provide a short and direct response. 0.77. What is the ratio of the Expenditure(as % of GDP) in Swaziland in 2000 to that in 2002?
Give a very brief answer. 1.09. What is the ratio of the Expenditure(as % of GDP) in Azerbaijan in 2000 to that in 2003?
Your answer should be compact. 1.17. What is the ratio of the Expenditure(as % of GDP) in Jamaica in 2000 to that in 2003?
Offer a very short reply. 1.18. What is the ratio of the Expenditure(as % of GDP) of Saudi Arabia in 2000 to that in 2003?
Your answer should be compact. 0.83. What is the ratio of the Expenditure(as % of GDP) of Swaziland in 2000 to that in 2003?
Keep it short and to the point. 0.81. What is the ratio of the Expenditure(as % of GDP) in Azerbaijan in 2000 to that in 2004?
Your response must be concise. 1.12. What is the ratio of the Expenditure(as % of GDP) of Jamaica in 2000 to that in 2004?
Ensure brevity in your answer.  1.28. What is the ratio of the Expenditure(as % of GDP) of Saudi Arabia in 2000 to that in 2004?
Offer a terse response. 0.95. What is the ratio of the Expenditure(as % of GDP) of Swaziland in 2000 to that in 2004?
Your answer should be very brief. 0.86. What is the ratio of the Expenditure(as % of GDP) of Azerbaijan in 2000 to that in 2005?
Keep it short and to the point. 1.3. What is the ratio of the Expenditure(as % of GDP) of Jamaica in 2000 to that in 2005?
Offer a very short reply. 1.09. What is the ratio of the Expenditure(as % of GDP) in Saudi Arabia in 2000 to that in 2005?
Your answer should be compact. 1.09. What is the ratio of the Expenditure(as % of GDP) in Swaziland in 2000 to that in 2005?
Provide a succinct answer. 0.74. What is the ratio of the Expenditure(as % of GDP) of Azerbaijan in 2000 to that in 2008?
Your answer should be very brief. 1.58. What is the ratio of the Expenditure(as % of GDP) in Jamaica in 2000 to that in 2008?
Offer a terse response. 0.81. What is the ratio of the Expenditure(as % of GDP) of Saudi Arabia in 2000 to that in 2008?
Ensure brevity in your answer.  1.16. What is the ratio of the Expenditure(as % of GDP) of Swaziland in 2000 to that in 2008?
Your answer should be very brief. 0.73. What is the ratio of the Expenditure(as % of GDP) in Azerbaijan in 2001 to that in 2002?
Your answer should be very brief. 1.11. What is the ratio of the Expenditure(as % of GDP) in Jamaica in 2001 to that in 2002?
Offer a very short reply. 1. What is the ratio of the Expenditure(as % of GDP) of Saudi Arabia in 2001 to that in 2002?
Make the answer very short. 1.01. What is the ratio of the Expenditure(as % of GDP) in Swaziland in 2001 to that in 2002?
Give a very brief answer. 1.09. What is the ratio of the Expenditure(as % of GDP) in Azerbaijan in 2001 to that in 2003?
Provide a succinct answer. 1.07. What is the ratio of the Expenditure(as % of GDP) of Jamaica in 2001 to that in 2003?
Keep it short and to the point. 1.27. What is the ratio of the Expenditure(as % of GDP) in Saudi Arabia in 2001 to that in 2003?
Provide a short and direct response. 1.09. What is the ratio of the Expenditure(as % of GDP) in Swaziland in 2001 to that in 2003?
Ensure brevity in your answer.  0.81. What is the ratio of the Expenditure(as % of GDP) in Azerbaijan in 2001 to that in 2004?
Your response must be concise. 1.02. What is the ratio of the Expenditure(as % of GDP) in Jamaica in 2001 to that in 2004?
Your response must be concise. 1.38. What is the ratio of the Expenditure(as % of GDP) of Saudi Arabia in 2001 to that in 2004?
Provide a short and direct response. 1.24. What is the ratio of the Expenditure(as % of GDP) of Swaziland in 2001 to that in 2004?
Your answer should be very brief. 0.86. What is the ratio of the Expenditure(as % of GDP) in Azerbaijan in 2001 to that in 2005?
Give a very brief answer. 1.18. What is the ratio of the Expenditure(as % of GDP) of Jamaica in 2001 to that in 2005?
Make the answer very short. 1.17. What is the ratio of the Expenditure(as % of GDP) in Saudi Arabia in 2001 to that in 2005?
Ensure brevity in your answer.  1.43. What is the ratio of the Expenditure(as % of GDP) in Swaziland in 2001 to that in 2005?
Offer a terse response. 0.74. What is the ratio of the Expenditure(as % of GDP) of Azerbaijan in 2001 to that in 2008?
Keep it short and to the point. 1.44. What is the ratio of the Expenditure(as % of GDP) of Jamaica in 2001 to that in 2008?
Give a very brief answer. 0.87. What is the ratio of the Expenditure(as % of GDP) of Saudi Arabia in 2001 to that in 2008?
Your answer should be compact. 1.51. What is the ratio of the Expenditure(as % of GDP) in Swaziland in 2001 to that in 2008?
Make the answer very short. 0.73. What is the ratio of the Expenditure(as % of GDP) of Azerbaijan in 2002 to that in 2003?
Your answer should be compact. 0.96. What is the ratio of the Expenditure(as % of GDP) in Jamaica in 2002 to that in 2003?
Offer a terse response. 1.28. What is the ratio of the Expenditure(as % of GDP) in Saudi Arabia in 2002 to that in 2003?
Keep it short and to the point. 1.07. What is the ratio of the Expenditure(as % of GDP) in Swaziland in 2002 to that in 2003?
Your response must be concise. 0.75. What is the ratio of the Expenditure(as % of GDP) in Azerbaijan in 2002 to that in 2004?
Provide a succinct answer. 0.92. What is the ratio of the Expenditure(as % of GDP) of Jamaica in 2002 to that in 2004?
Offer a very short reply. 1.39. What is the ratio of the Expenditure(as % of GDP) in Saudi Arabia in 2002 to that in 2004?
Offer a terse response. 1.22. What is the ratio of the Expenditure(as % of GDP) of Swaziland in 2002 to that in 2004?
Provide a short and direct response. 0.79. What is the ratio of the Expenditure(as % of GDP) of Azerbaijan in 2002 to that in 2005?
Provide a short and direct response. 1.06. What is the ratio of the Expenditure(as % of GDP) in Jamaica in 2002 to that in 2005?
Make the answer very short. 1.18. What is the ratio of the Expenditure(as % of GDP) of Saudi Arabia in 2002 to that in 2005?
Provide a succinct answer. 1.41. What is the ratio of the Expenditure(as % of GDP) in Swaziland in 2002 to that in 2005?
Your answer should be very brief. 0.68. What is the ratio of the Expenditure(as % of GDP) of Azerbaijan in 2002 to that in 2008?
Make the answer very short. 1.29. What is the ratio of the Expenditure(as % of GDP) of Jamaica in 2002 to that in 2008?
Your response must be concise. 0.88. What is the ratio of the Expenditure(as % of GDP) in Saudi Arabia in 2002 to that in 2008?
Offer a very short reply. 1.49. What is the ratio of the Expenditure(as % of GDP) in Swaziland in 2002 to that in 2008?
Offer a very short reply. 0.68. What is the ratio of the Expenditure(as % of GDP) in Azerbaijan in 2003 to that in 2004?
Your answer should be compact. 0.95. What is the ratio of the Expenditure(as % of GDP) of Jamaica in 2003 to that in 2004?
Ensure brevity in your answer.  1.09. What is the ratio of the Expenditure(as % of GDP) in Saudi Arabia in 2003 to that in 2004?
Offer a terse response. 1.14. What is the ratio of the Expenditure(as % of GDP) of Swaziland in 2003 to that in 2004?
Offer a very short reply. 1.06. What is the ratio of the Expenditure(as % of GDP) in Azerbaijan in 2003 to that in 2005?
Your response must be concise. 1.1. What is the ratio of the Expenditure(as % of GDP) in Jamaica in 2003 to that in 2005?
Offer a very short reply. 0.92. What is the ratio of the Expenditure(as % of GDP) of Saudi Arabia in 2003 to that in 2005?
Provide a succinct answer. 1.32. What is the ratio of the Expenditure(as % of GDP) of Swaziland in 2003 to that in 2005?
Offer a terse response. 0.92. What is the ratio of the Expenditure(as % of GDP) of Azerbaijan in 2003 to that in 2008?
Your response must be concise. 1.35. What is the ratio of the Expenditure(as % of GDP) in Jamaica in 2003 to that in 2008?
Provide a succinct answer. 0.69. What is the ratio of the Expenditure(as % of GDP) in Saudi Arabia in 2003 to that in 2008?
Provide a short and direct response. 1.39. What is the ratio of the Expenditure(as % of GDP) in Swaziland in 2003 to that in 2008?
Your answer should be compact. 0.91. What is the ratio of the Expenditure(as % of GDP) of Azerbaijan in 2004 to that in 2005?
Ensure brevity in your answer.  1.16. What is the ratio of the Expenditure(as % of GDP) in Jamaica in 2004 to that in 2005?
Offer a terse response. 0.85. What is the ratio of the Expenditure(as % of GDP) of Saudi Arabia in 2004 to that in 2005?
Give a very brief answer. 1.16. What is the ratio of the Expenditure(as % of GDP) of Swaziland in 2004 to that in 2005?
Make the answer very short. 0.86. What is the ratio of the Expenditure(as % of GDP) in Azerbaijan in 2004 to that in 2008?
Provide a succinct answer. 1.41. What is the ratio of the Expenditure(as % of GDP) in Jamaica in 2004 to that in 2008?
Your response must be concise. 0.63. What is the ratio of the Expenditure(as % of GDP) of Saudi Arabia in 2004 to that in 2008?
Make the answer very short. 1.22. What is the ratio of the Expenditure(as % of GDP) of Swaziland in 2004 to that in 2008?
Your answer should be very brief. 0.85. What is the ratio of the Expenditure(as % of GDP) in Azerbaijan in 2005 to that in 2008?
Provide a short and direct response. 1.22. What is the ratio of the Expenditure(as % of GDP) in Jamaica in 2005 to that in 2008?
Give a very brief answer. 0.75. What is the ratio of the Expenditure(as % of GDP) in Saudi Arabia in 2005 to that in 2008?
Your answer should be compact. 1.06. What is the ratio of the Expenditure(as % of GDP) of Swaziland in 2005 to that in 2008?
Your response must be concise. 0.99. What is the difference between the highest and the second highest Expenditure(as % of GDP) in Azerbaijan?
Provide a short and direct response. 0.35. What is the difference between the highest and the second highest Expenditure(as % of GDP) of Jamaica?
Keep it short and to the point. 0.76. What is the difference between the highest and the second highest Expenditure(as % of GDP) in Saudi Arabia?
Your response must be concise. 0.09. What is the difference between the highest and the second highest Expenditure(as % of GDP) in Swaziland?
Give a very brief answer. 0.1. What is the difference between the highest and the lowest Expenditure(as % of GDP) of Azerbaijan?
Your answer should be compact. 1.41. What is the difference between the highest and the lowest Expenditure(as % of GDP) in Jamaica?
Your answer should be compact. 2.28. What is the difference between the highest and the lowest Expenditure(as % of GDP) of Saudi Arabia?
Make the answer very short. 2.63. What is the difference between the highest and the lowest Expenditure(as % of GDP) of Swaziland?
Ensure brevity in your answer.  2.44. 